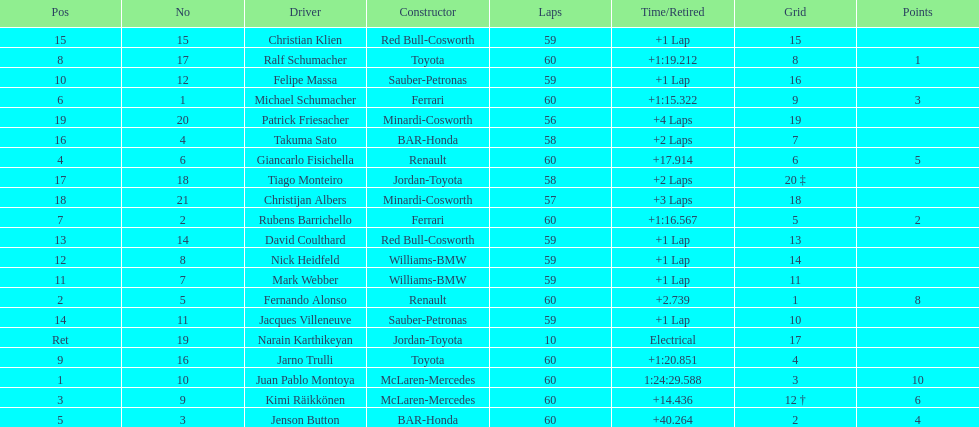Is there a points difference between the 9th position and 19th position on the list? No. 